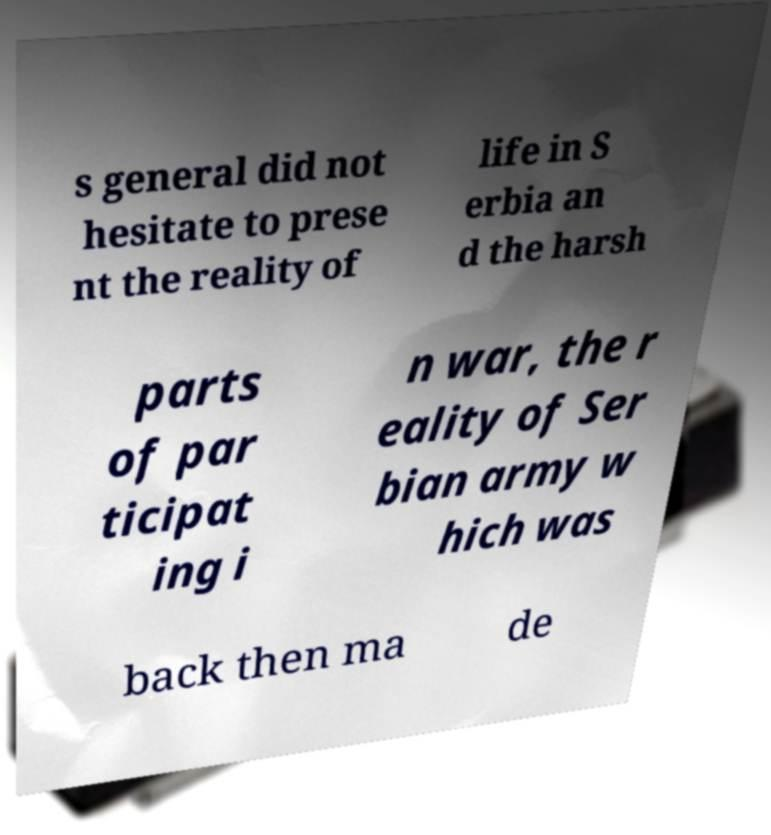Could you assist in decoding the text presented in this image and type it out clearly? s general did not hesitate to prese nt the reality of life in S erbia an d the harsh parts of par ticipat ing i n war, the r eality of Ser bian army w hich was back then ma de 